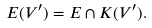<formula> <loc_0><loc_0><loc_500><loc_500>E ( V ^ { \prime } ) = E \cap K ( V ^ { \prime } ) .</formula> 